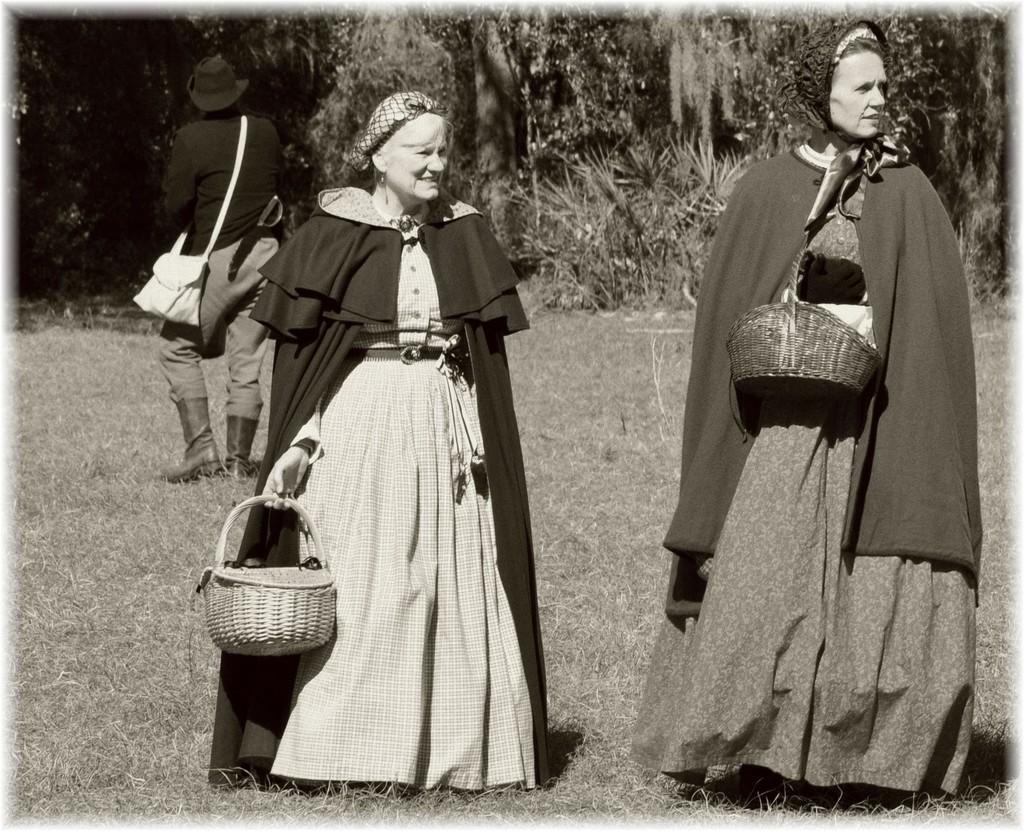Could you give a brief overview of what you see in this image? In this image, we can see two women standing, in the background, we can see a person standing, there is grass on the ground, we can see some trees. 